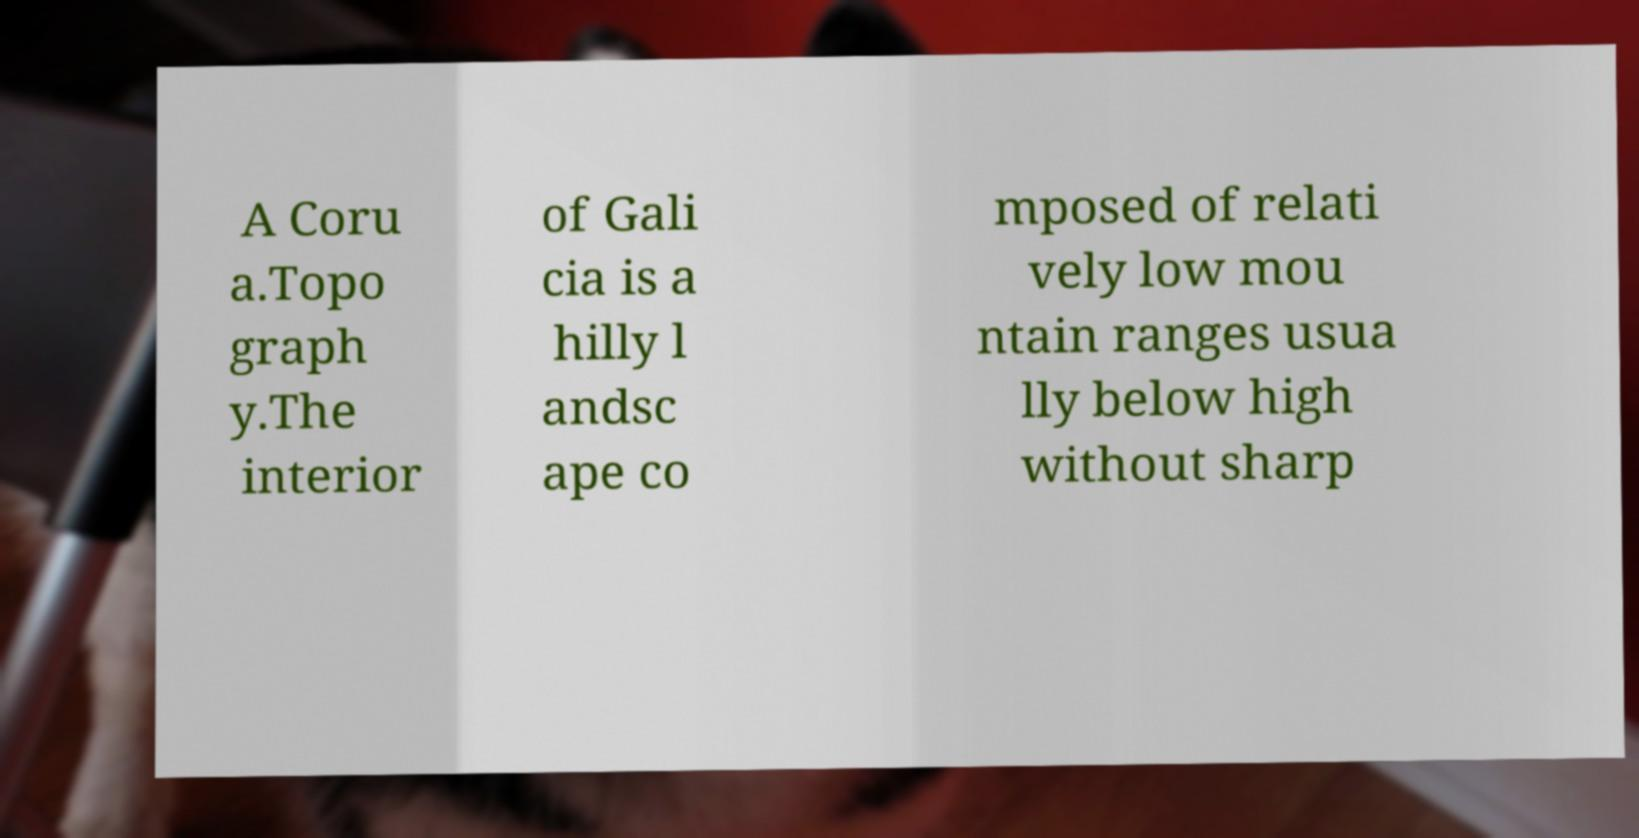Can you accurately transcribe the text from the provided image for me? A Coru a.Topo graph y.The interior of Gali cia is a hilly l andsc ape co mposed of relati vely low mou ntain ranges usua lly below high without sharp 